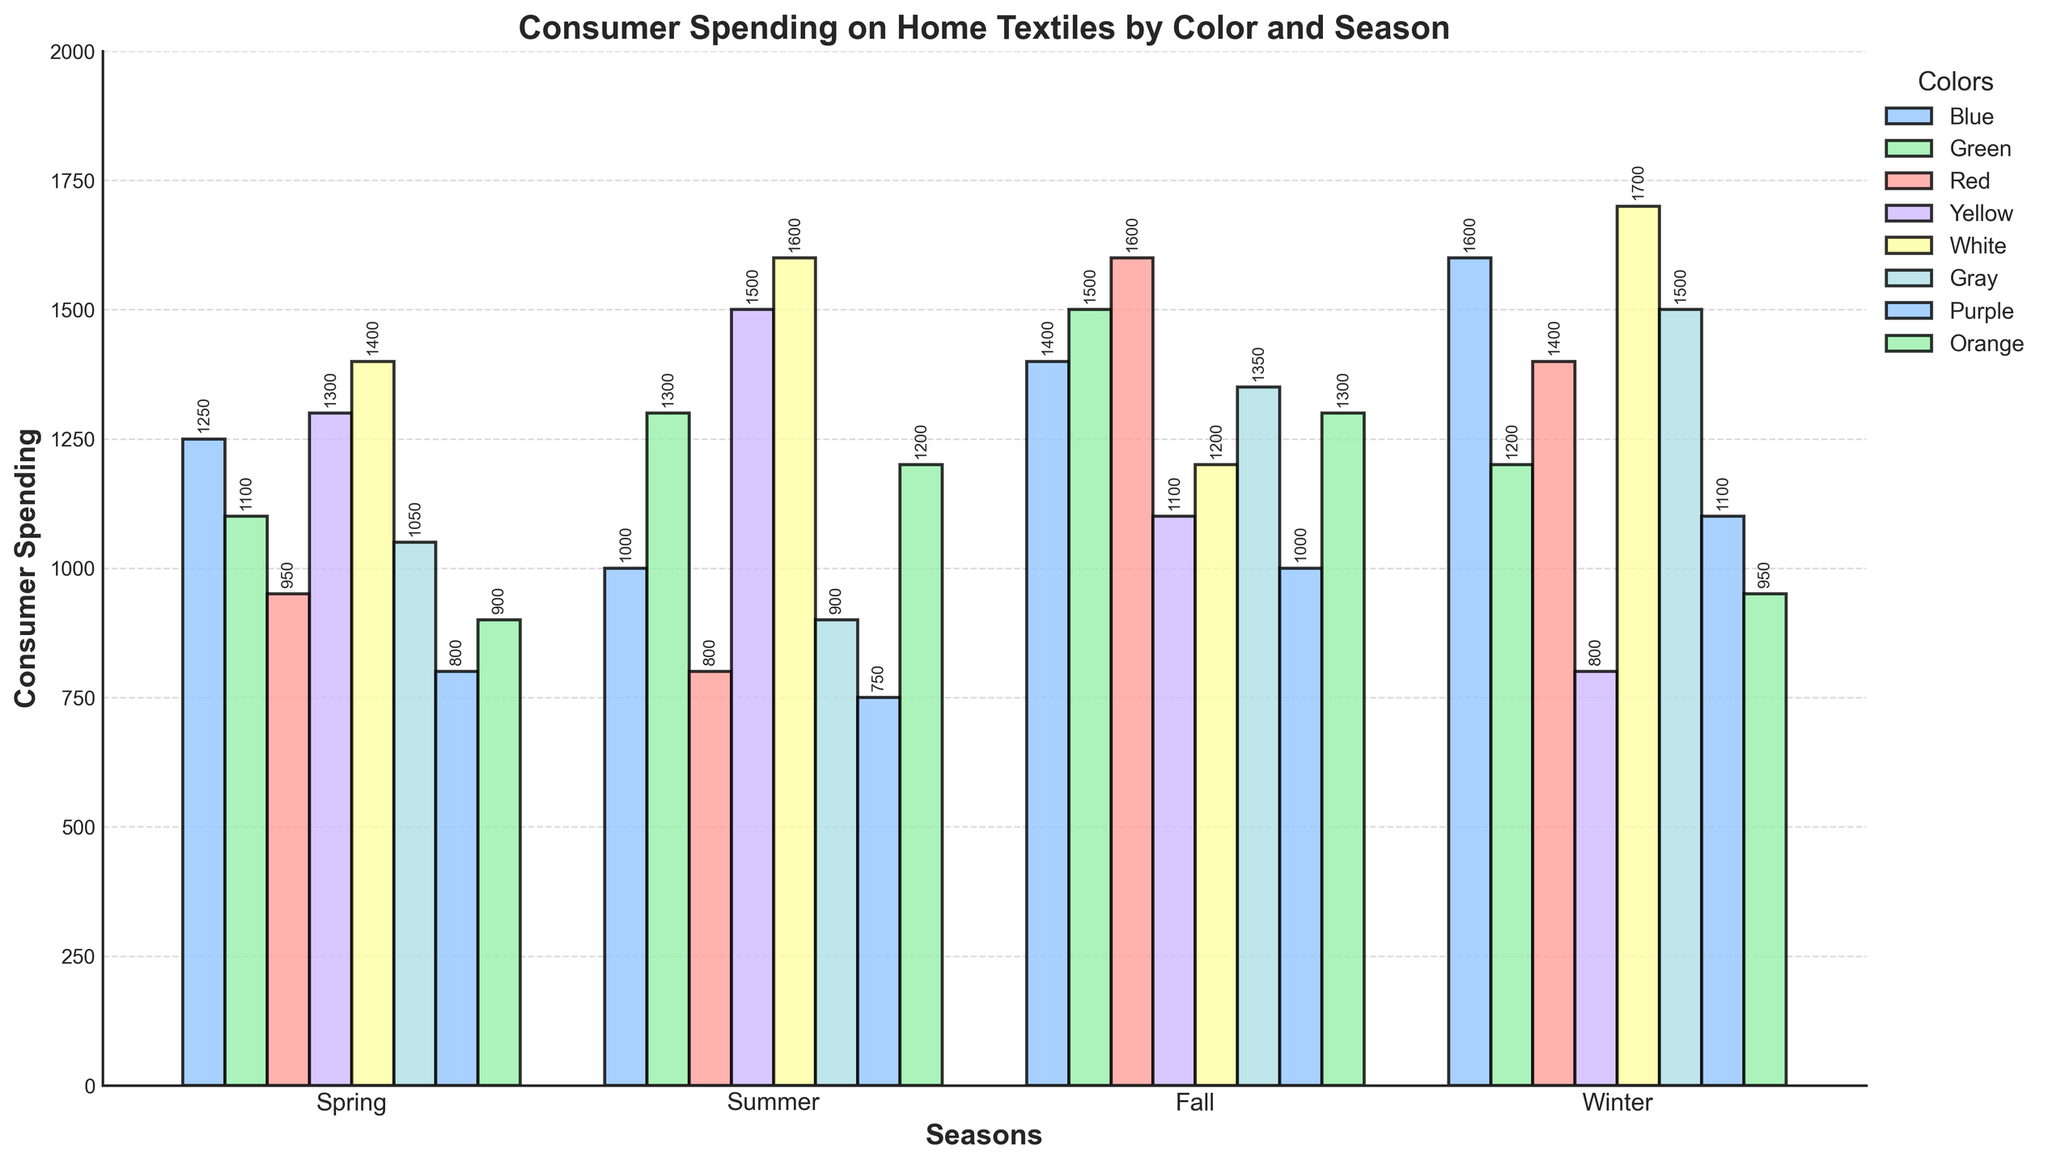which season sees the highest consumer spending on white textiles? to determine the season with the highest spending on white textiles, look for the highest bar in the "White" category. the bar for winter is the tallest, indicating the highest spending on white textiles.
Answer: winter compare consumer spending on gray textiles between fall and winter; which season has higher spending? to compare the spending, observe the height of the bars for gray textiles in fall and winter. the bar for winter is higher than the bar for fall, indicating higher spending in winter.
Answer: winter what is the difference in consumer spending on red textiles between spring and winter? to find the difference, subtract the spending in spring from the spending in winter for red textiles. winter: 1400, spring: 950. 1400 - 950 = 450
Answer: 450 which color sees the least variation in consumer spending across seasons? to determine the color with the least variation, look for bars that appear roughly the same height across all seasons. purple has bars that are relatively uniform, indicating the least variation in spending.
Answer: purple which season has the lowest overall consumer spending on home textiles? to find the season with the lowest overall spending, visually sum the heights of all bars in each season. the bars in spring are generally lower than other seasons, indicating the lowest overall spending.
Answer: spring what is the average consumer spending on blue textiles across all seasons? to calculate the average, sum the spending on blue textiles for all seasons and divide by the number of seasons. (1250 + 1000 + 1400 + 1600)/4 = 5250/4 = 1312.5
Answer: 1312.5 how does summer spending on yellow textiles compare to winter spending on yellow textiles? to compare, observe the heights of the bars for yellow textiles in summer and winter. the bar for summer is significantly higher than the bar for winter, indicating greater spending in summer.
Answer: summer which color experiences the highest spending increase from fall to winter? to find the color with the highest increase, compare the height of each bar from fall to winter and calculate the difference. gray increases from 1350 in fall to 1500 in winter, an increase of 150, which appears to be the highest.
Answer: gray during which season is consumer spending on green textiles highest? to find the season with the highest spending, look for the tallest bar in the "Green" category. fall has the tallest bar, indicating the highest spending.
Answer: fall compare consumer spending on orange textiles in spring and fall; are they equal? observe the bars for orange textiles in spring and fall. in spring, the bar is at 900, while in fall, it is at 1300. the spending is not equal.
Answer: no 